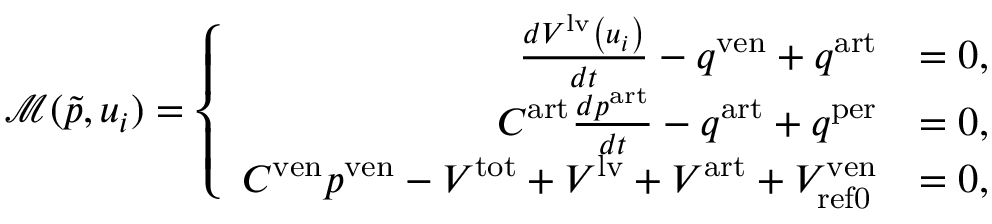Convert formula to latex. <formula><loc_0><loc_0><loc_500><loc_500>\mathcal { M } ( \tilde { p } , u _ { i } ) = \left \{ \begin{array} { r l } { \frac { d V ^ { l v } \left ( u _ { i } \right ) } { d t } - q ^ { v e n } + q ^ { a r t } } & { = 0 , } \\ { C ^ { a r t } \frac { d p ^ { a r t } } { d t } - q ^ { a r t } + q ^ { p e r } } & { = 0 , } \\ { C ^ { v e n } p ^ { v e n } - V ^ { t o t } + V ^ { l v } + V ^ { a r t } + V _ { r e f 0 } ^ { v e n } } & { = 0 , } \end{array}</formula> 